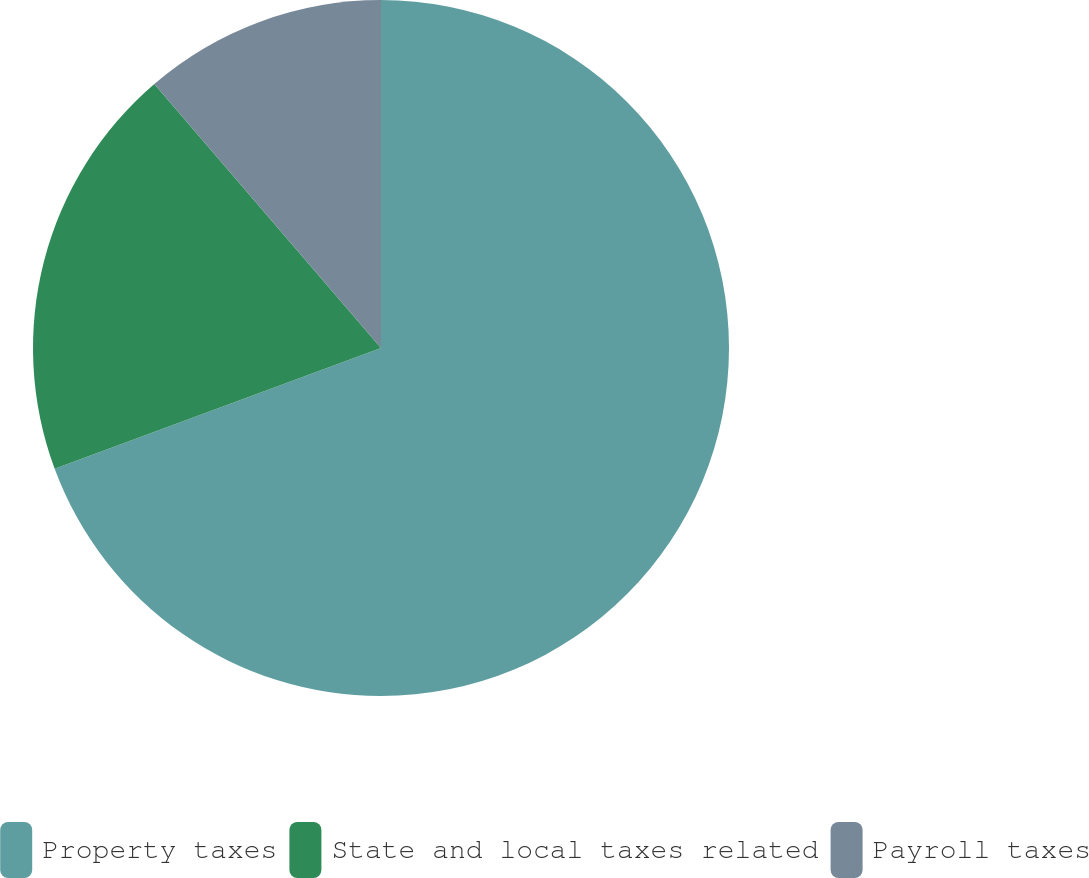Convert chart. <chart><loc_0><loc_0><loc_500><loc_500><pie_chart><fcel>Property taxes<fcel>State and local taxes related<fcel>Payroll taxes<nl><fcel>69.35%<fcel>19.35%<fcel>11.29%<nl></chart> 